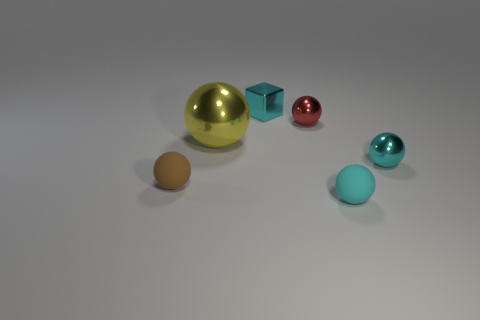There is a tiny matte ball to the right of the small cyan object that is behind the small shiny object that is right of the tiny red object; what is its color?
Offer a terse response. Cyan. Is the material of the yellow thing the same as the brown object?
Provide a short and direct response. No. What number of yellow objects are cubes or metallic balls?
Give a very brief answer. 1. What number of cyan shiny objects are in front of the big yellow shiny ball?
Your answer should be compact. 1. Is the number of red metallic balls greater than the number of tiny metal spheres?
Your answer should be very brief. No. What shape is the small red shiny thing that is on the right side of the large sphere that is left of the small red thing?
Your answer should be compact. Sphere. Do the block and the large object have the same color?
Ensure brevity in your answer.  No. Is the number of small rubber things that are right of the big yellow shiny ball greater than the number of tiny purple shiny cubes?
Offer a very short reply. Yes. There is a red object that is left of the cyan metallic sphere; what number of shiny cubes are behind it?
Ensure brevity in your answer.  1. Is the material of the cyan thing to the left of the tiny red shiny sphere the same as the tiny ball right of the tiny cyan matte object?
Keep it short and to the point. Yes. 